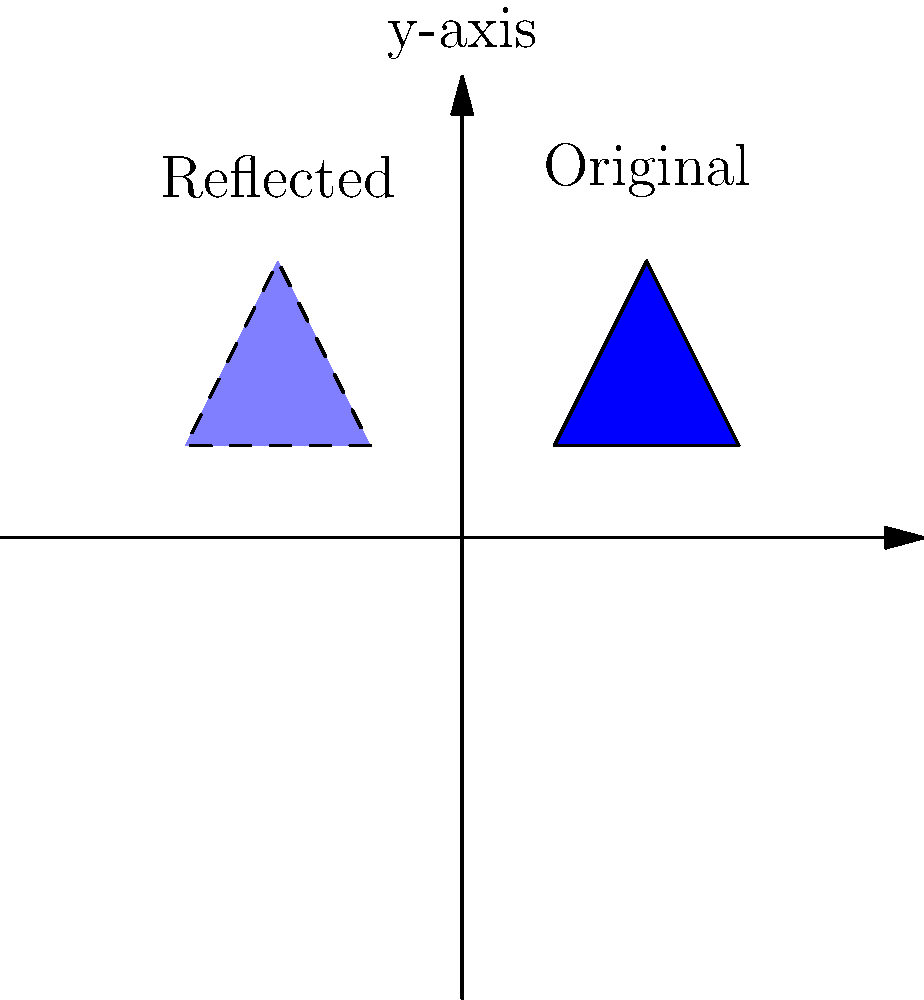Your Marseille-loving relative proudly shows you their team's new jersey design, represented by the blue triangle in the first quadrant. To playfully tease them, you decide to reflect the design across the y-axis. What will be the coordinates of the reflected triangle's vertices? To reflect a point across the y-axis, we keep the y-coordinate the same and negate the x-coordinate. Let's go through this step-by-step:

1. Identify the original coordinates:
   Point A: (1, 1)
   Point B: (3, 1)
   Point C: (2, 3)

2. Reflect each point across the y-axis:
   A': (-1, 1)  [Negate x-coordinate of A]
   B': (-3, 1)  [Negate x-coordinate of B]
   C': (-2, 3)  [Negate x-coordinate of C]

3. The reflected triangle will have vertices at these new coordinates.

This reflection creates a mirror image of the original jersey design on the left side of the y-axis, perfect for teasing your Marseille-loving relative about their team's "backwards" design.
Answer: $(-1, 1)$, $(-3, 1)$, $(-2, 3)$ 